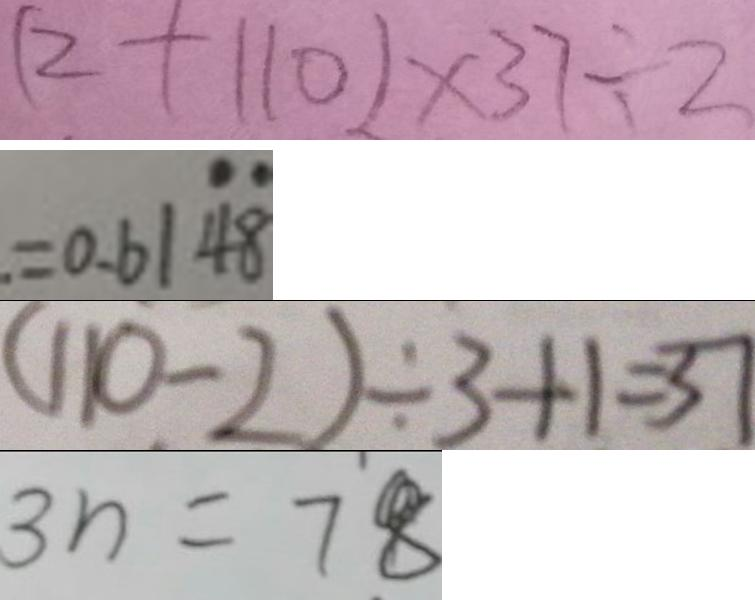<formula> <loc_0><loc_0><loc_500><loc_500>( 2 + 1 1 0 ) \times 3 7 \div 2 
 . = 0 . 6 1 \dot { 4 } \dot { 8 } 
 ( 1 1 0 - 2 ) \div 3 + 1 = 3 7 
 3 n = 7 8</formula> 